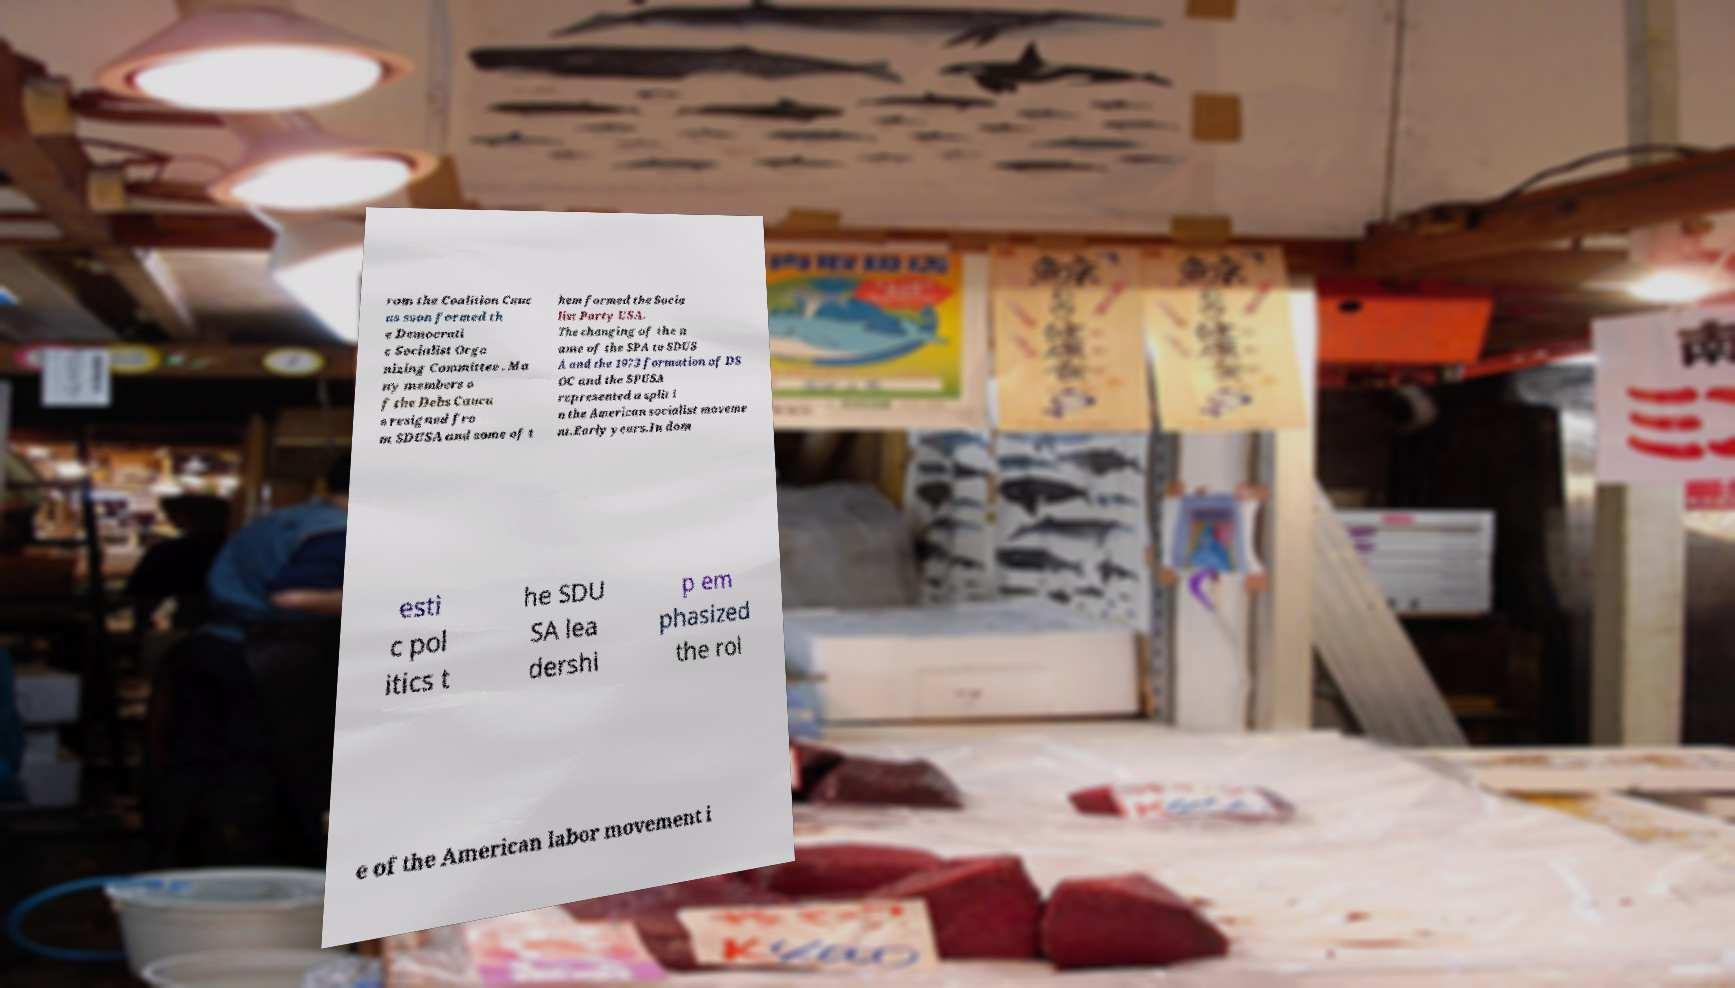Please identify and transcribe the text found in this image. rom the Coalition Cauc us soon formed th e Democrati c Socialist Orga nizing Committee . Ma ny members o f the Debs Caucu s resigned fro m SDUSA and some of t hem formed the Socia list Party USA. The changing of the n ame of the SPA to SDUS A and the 1973 formation of DS OC and the SPUSA represented a split i n the American socialist moveme nt.Early years.In dom esti c pol itics t he SDU SA lea dershi p em phasized the rol e of the American labor movement i 